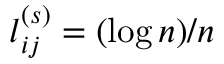<formula> <loc_0><loc_0><loc_500><loc_500>l _ { i j } ^ { ( s ) } = ( \log n ) / n</formula> 